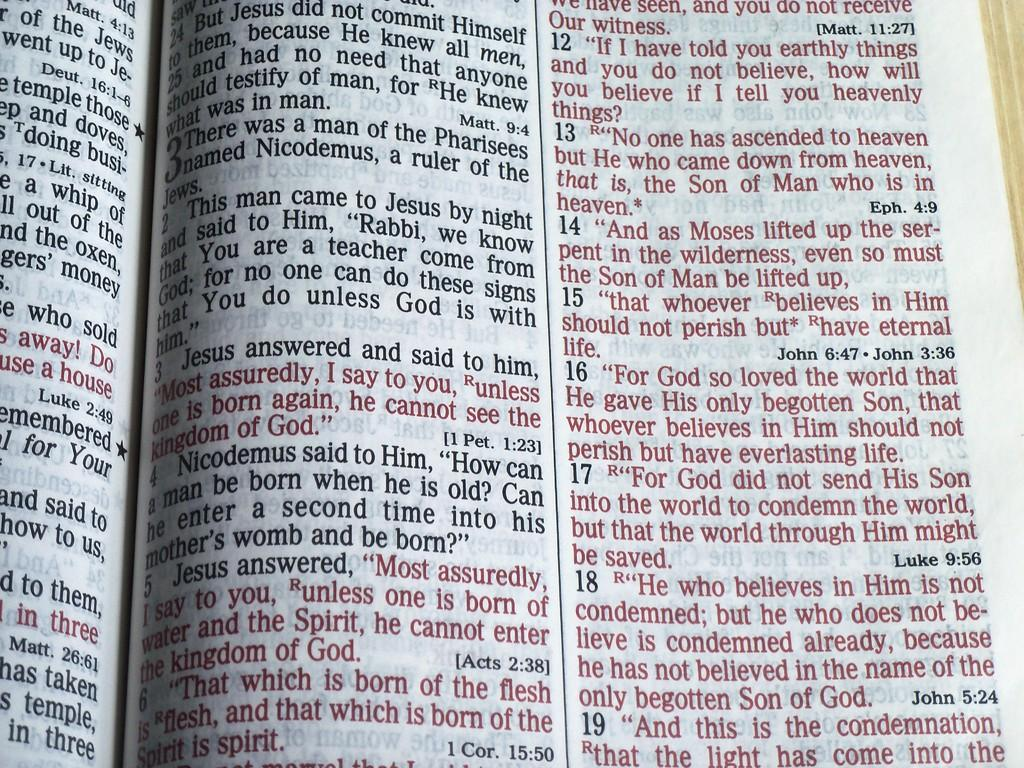<image>
Create a compact narrative representing the image presented. Bible pages display verses by Luke, John, and Matthew, among others. 